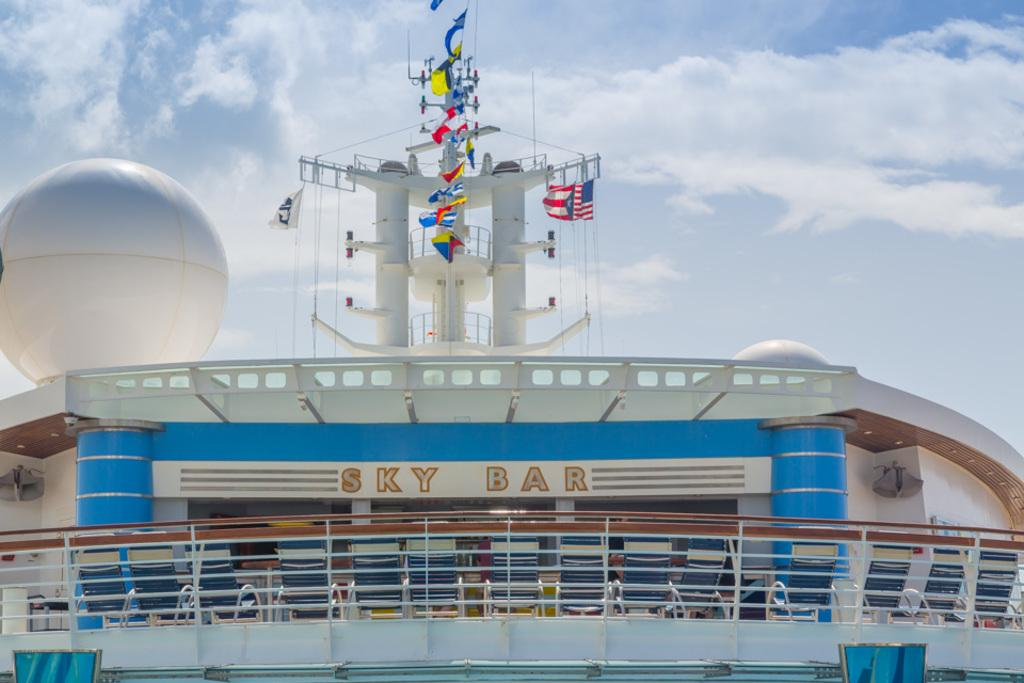What type of view is shown in the image? The image has an outside view. What is located in the foreground of the image? There is a building in the foreground. What can be seen on the building? The building contains some flags. What can be seen in the background of the image? The sky is visible in the background. Who is teaching a class in the image? There is no class or teaching activity depicted in the image. How many vans are parked in front of the building? There is no van present in the image. 